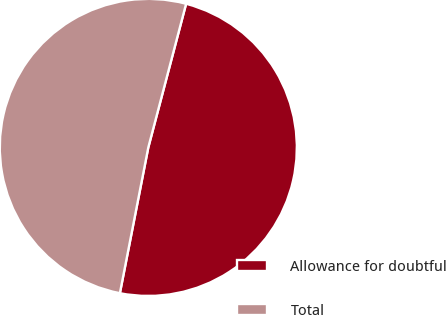Convert chart. <chart><loc_0><loc_0><loc_500><loc_500><pie_chart><fcel>Allowance for doubtful<fcel>Total<nl><fcel>48.97%<fcel>51.03%<nl></chart> 